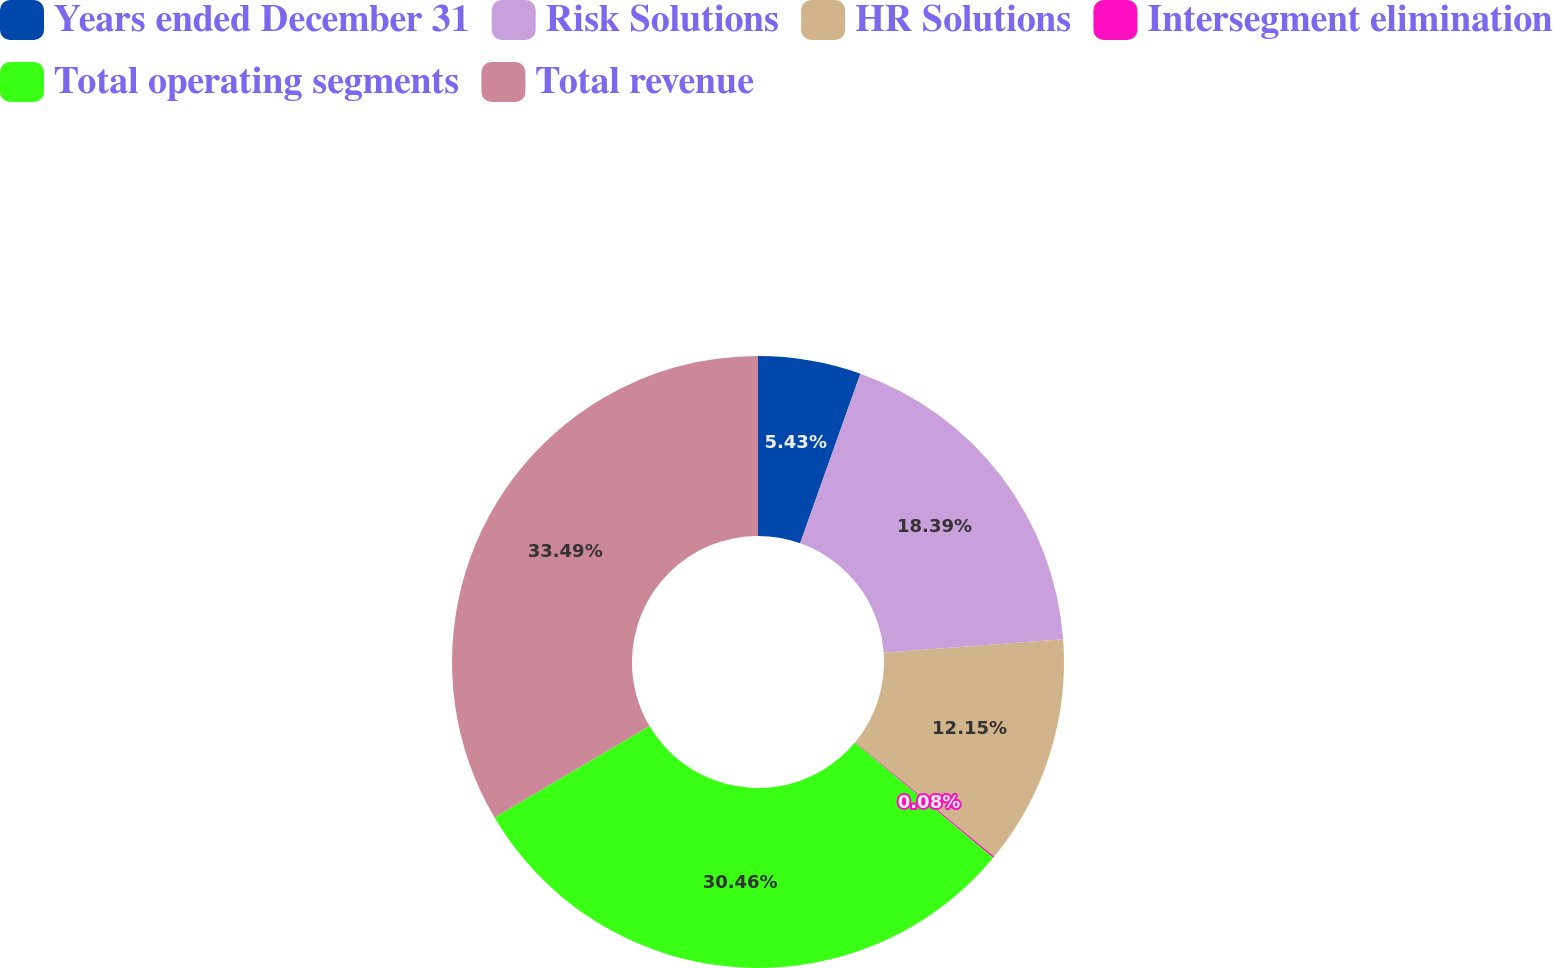Convert chart to OTSL. <chart><loc_0><loc_0><loc_500><loc_500><pie_chart><fcel>Years ended December 31<fcel>Risk Solutions<fcel>HR Solutions<fcel>Intersegment elimination<fcel>Total operating segments<fcel>Total revenue<nl><fcel>5.43%<fcel>18.39%<fcel>12.15%<fcel>0.08%<fcel>30.46%<fcel>33.49%<nl></chart> 